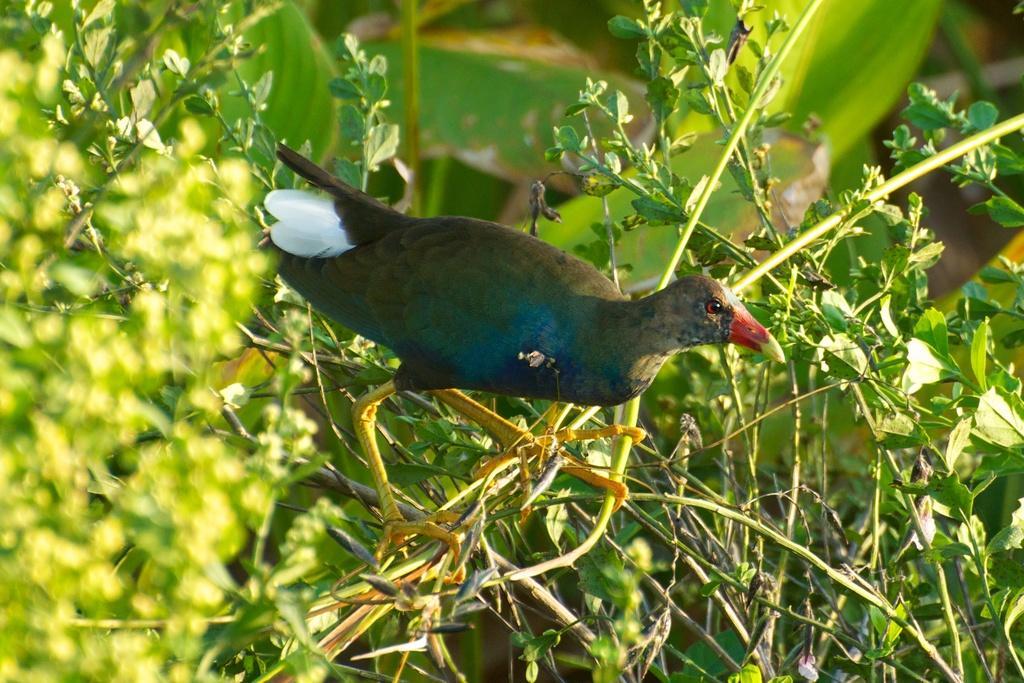Describe this image in one or two sentences. In the center of the image, we can see a bird and in the background, there are plants and we can see leaves. 